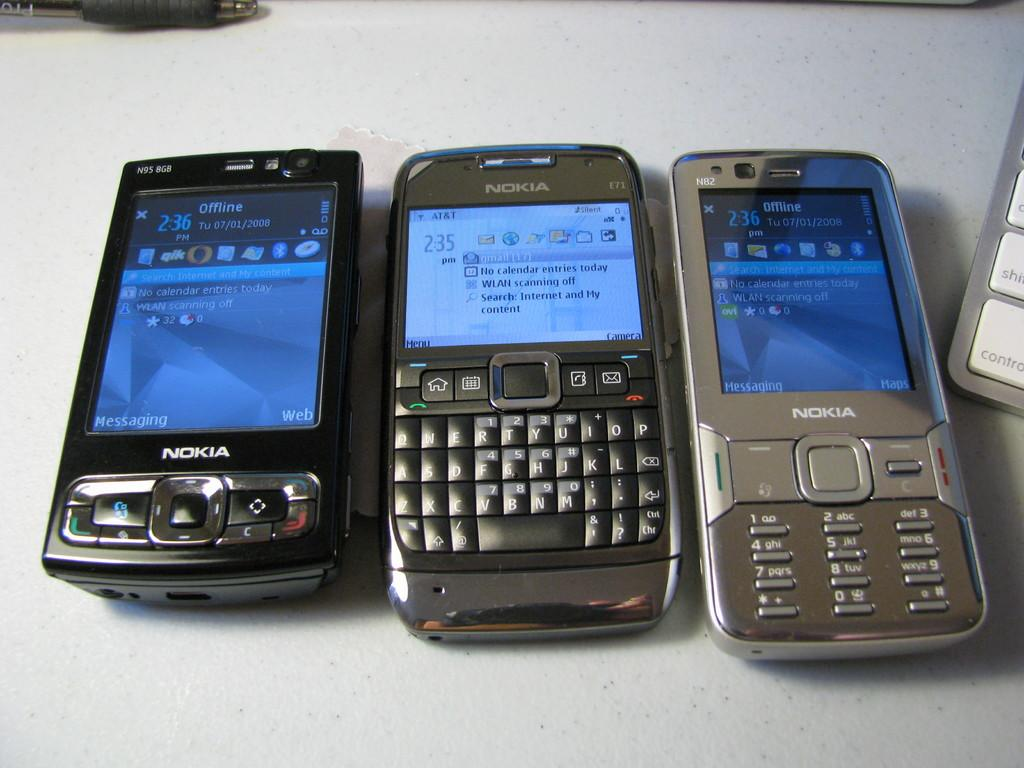<image>
Share a concise interpretation of the image provided. three Nokia cell phones on a white desk 